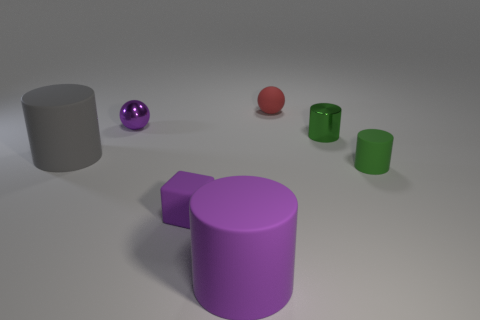Can you describe the number and types of objects present in the image? Certainly! In the image, there are six distinct objects. Starting from the left, there's a matte grey cylinder, followed by a shiny, reflective purple sphere. Moving right, we see a small matte red sphere, then a matte green cylinder that's shorter in height, followed by a glossy small purple sphere and, finally, on the far right, there's a matte green cup that matches the hue of the preceding green cylinder. 